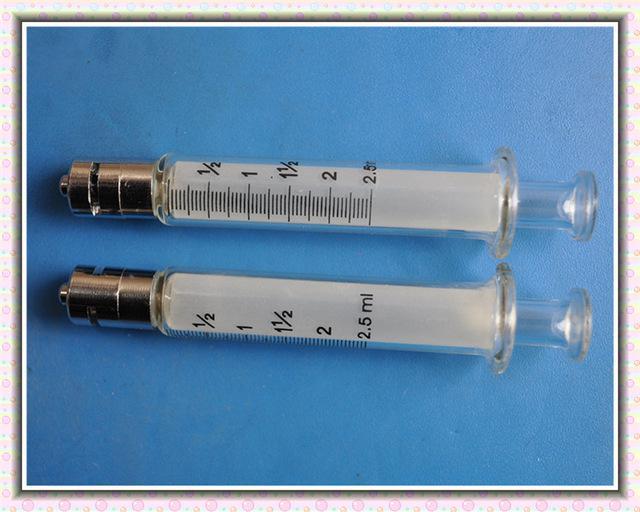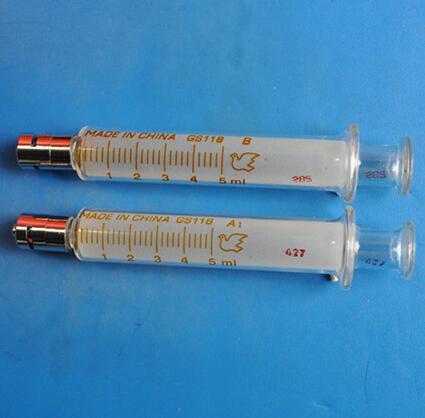The first image is the image on the left, the second image is the image on the right. Examine the images to the left and right. Is the description "The left and right image contains at total of five syringes with two needles." accurate? Answer yes or no. No. 